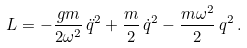<formula> <loc_0><loc_0><loc_500><loc_500>L = - \frac { g m } { 2 \omega ^ { 2 } } \, \ddot { q } ^ { 2 } + \frac { m } 2 \, \dot { q } ^ { 2 } - \frac { m \omega ^ { 2 } } 2 \, q ^ { 2 } \, .</formula> 